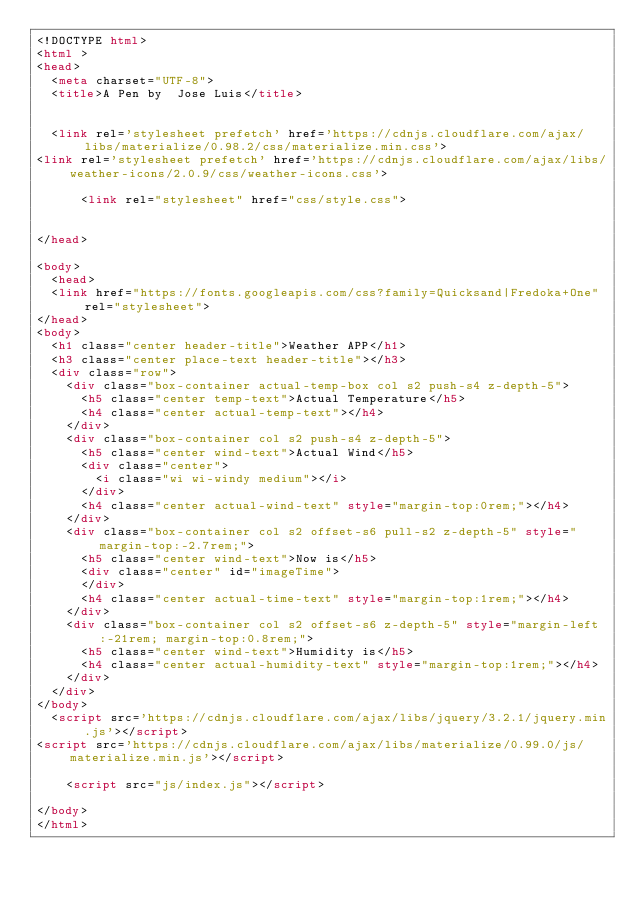<code> <loc_0><loc_0><loc_500><loc_500><_HTML_><!DOCTYPE html>
<html >
<head>
  <meta charset="UTF-8">
  <title>A Pen by  Jose Luis</title>
  
  
  <link rel='stylesheet prefetch' href='https://cdnjs.cloudflare.com/ajax/libs/materialize/0.98.2/css/materialize.min.css'>
<link rel='stylesheet prefetch' href='https://cdnjs.cloudflare.com/ajax/libs/weather-icons/2.0.9/css/weather-icons.css'>

      <link rel="stylesheet" href="css/style.css">

  
</head>

<body>
  <head>
  <link href="https://fonts.googleapis.com/css?family=Quicksand|Fredoka+One" rel="stylesheet">
</head>
<body>
  <h1 class="center header-title">Weather APP</h1>
  <h3 class="center place-text header-title"></h3>
  <div class="row">
    <div class="box-container actual-temp-box col s2 push-s4 z-depth-5">
      <h5 class="center temp-text">Actual Temperature</h5>
      <h4 class="center actual-temp-text"></h4>
    </div>
    <div class="box-container col s2 push-s4 z-depth-5">
      <h5 class="center wind-text">Actual Wind</h5>
      <div class="center">
        <i class="wi wi-windy medium"></i>
      </div>
      <h4 class="center actual-wind-text" style="margin-top:0rem;"></h4>
    </div>
    <div class="box-container col s2 offset-s6 pull-s2 z-depth-5" style="margin-top:-2.7rem;">
      <h5 class="center wind-text">Now is</h5>
      <div class="center" id="imageTime">
      </div>
      <h4 class="center actual-time-text" style="margin-top:1rem;"></h4>
    </div>
    <div class="box-container col s2 offset-s6 z-depth-5" style="margin-left:-21rem; margin-top:0.8rem;">
      <h5 class="center wind-text">Humidity is</h5>
      <h4 class="center actual-humidity-text" style="margin-top:1rem;"></h4>
    </div>
  </div>
</body>
  <script src='https://cdnjs.cloudflare.com/ajax/libs/jquery/3.2.1/jquery.min.js'></script>
<script src='https://cdnjs.cloudflare.com/ajax/libs/materialize/0.99.0/js/materialize.min.js'></script>

    <script src="js/index.js"></script>

</body>
</html>
</code> 